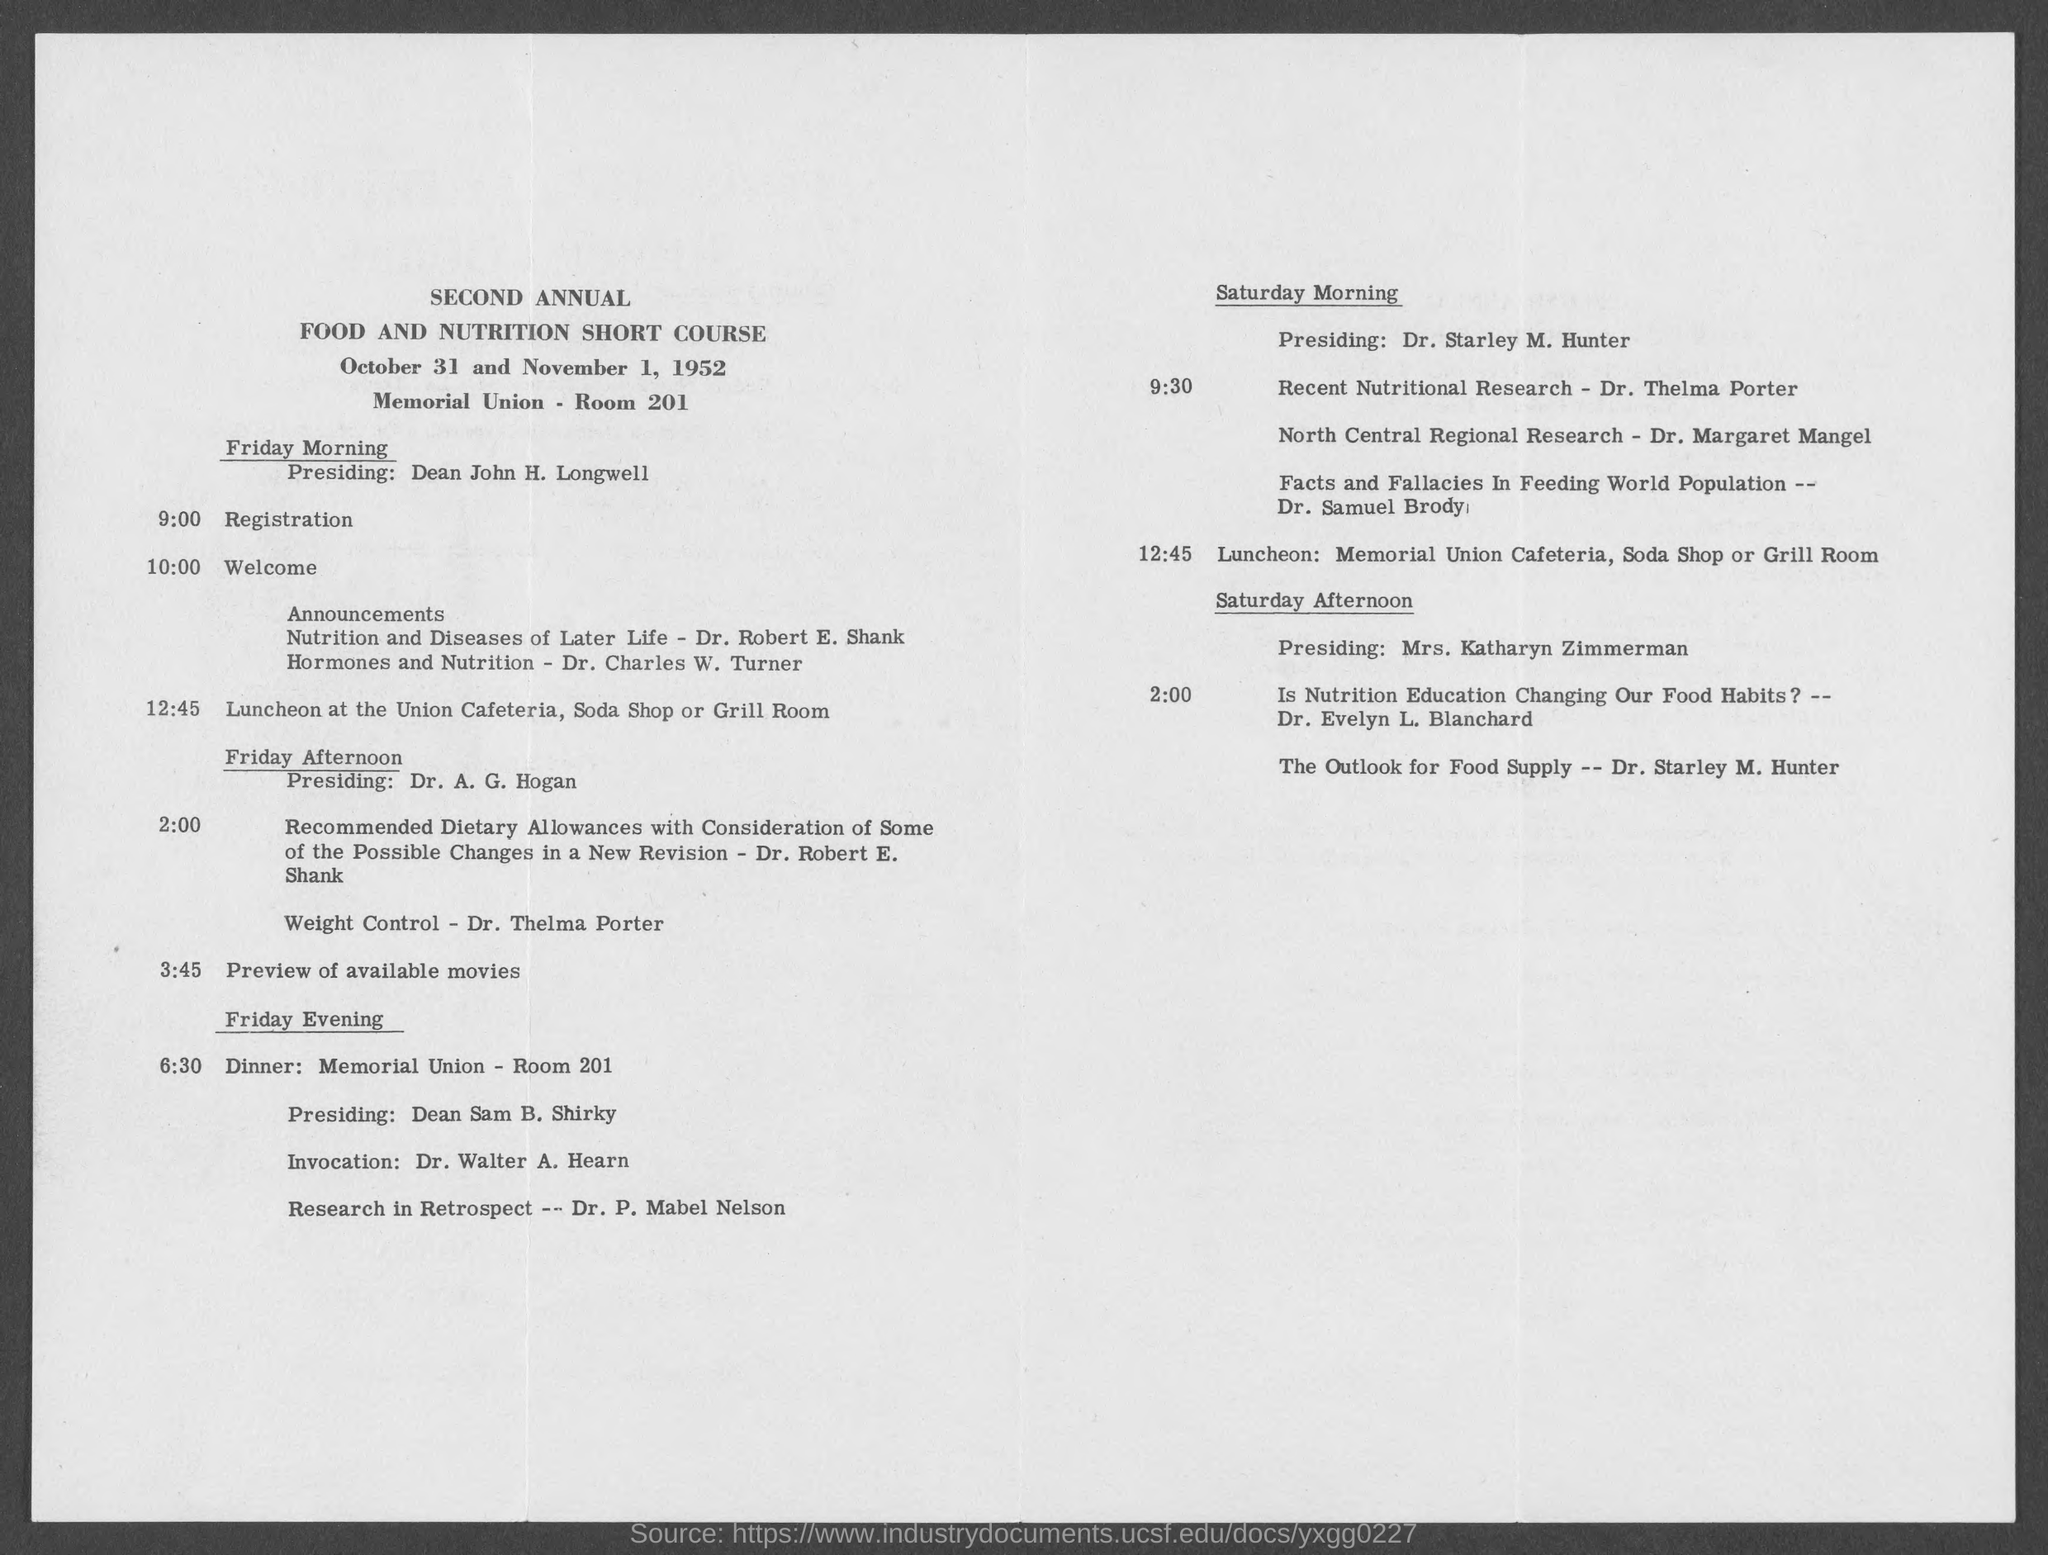Outline some significant characteristics in this image. The SECOND ANNUAL FOOD AND NUTRITION SHORT COURSE will be held. Dr. Charles W. Turner was the individual who discussed the topics of hormones and nutrition. On Friday morning, Dean John H. Longwell presided over the event. The duration of the Short Course was from October 31, 1952 to November 1, 1952. Dr. Samuel Brody discussed facts and fallacies in feeding the world population. 